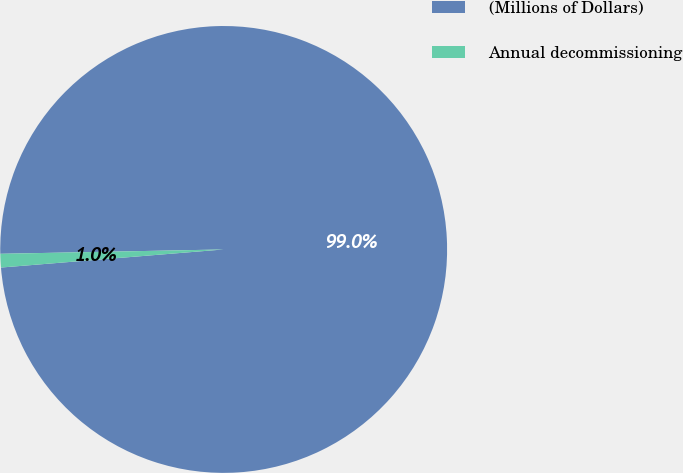Convert chart. <chart><loc_0><loc_0><loc_500><loc_500><pie_chart><fcel>(Millions of Dollars)<fcel>Annual decommissioning<nl><fcel>99.02%<fcel>0.98%<nl></chart> 